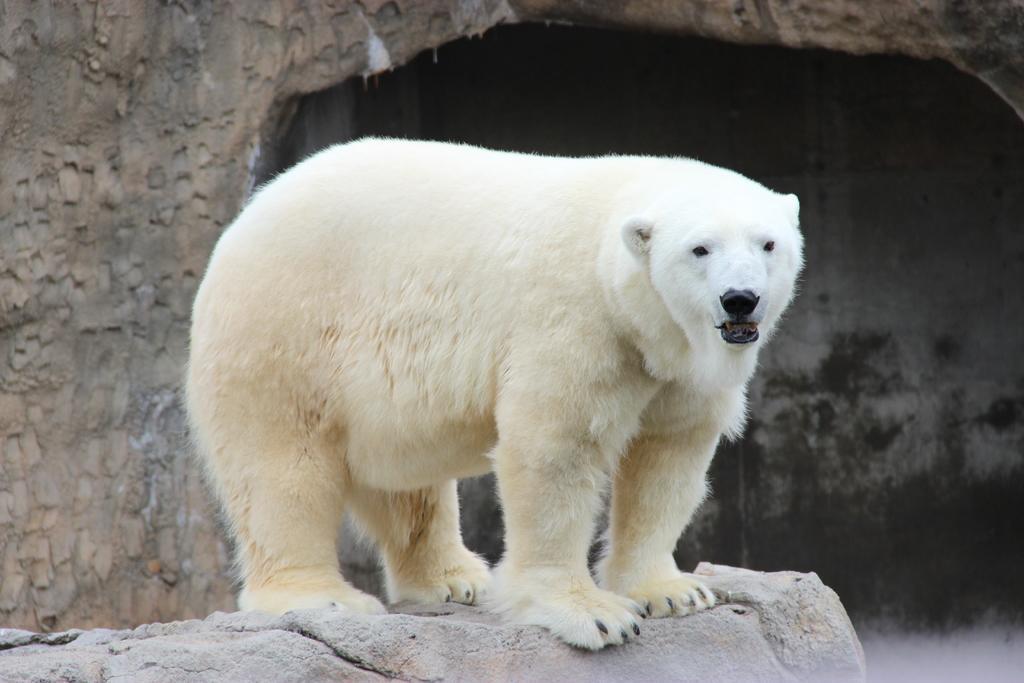Could you give a brief overview of what you see in this image? In this image we see an animal. There is a wall in the image. There is a rock in the image. 